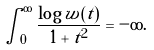<formula> <loc_0><loc_0><loc_500><loc_500>\int _ { 0 } ^ { \infty } \frac { \log w ( t ) } { 1 + t ^ { 2 } } = - \infty .</formula> 